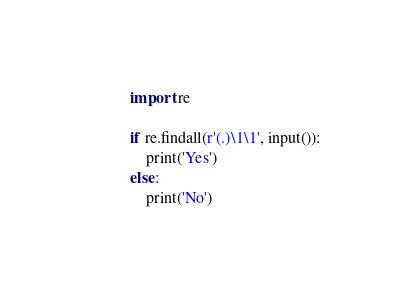<code> <loc_0><loc_0><loc_500><loc_500><_Python_>import re

if re.findall(r'(.)\1\1', input()):
    print('Yes')
else:
    print('No')
</code> 